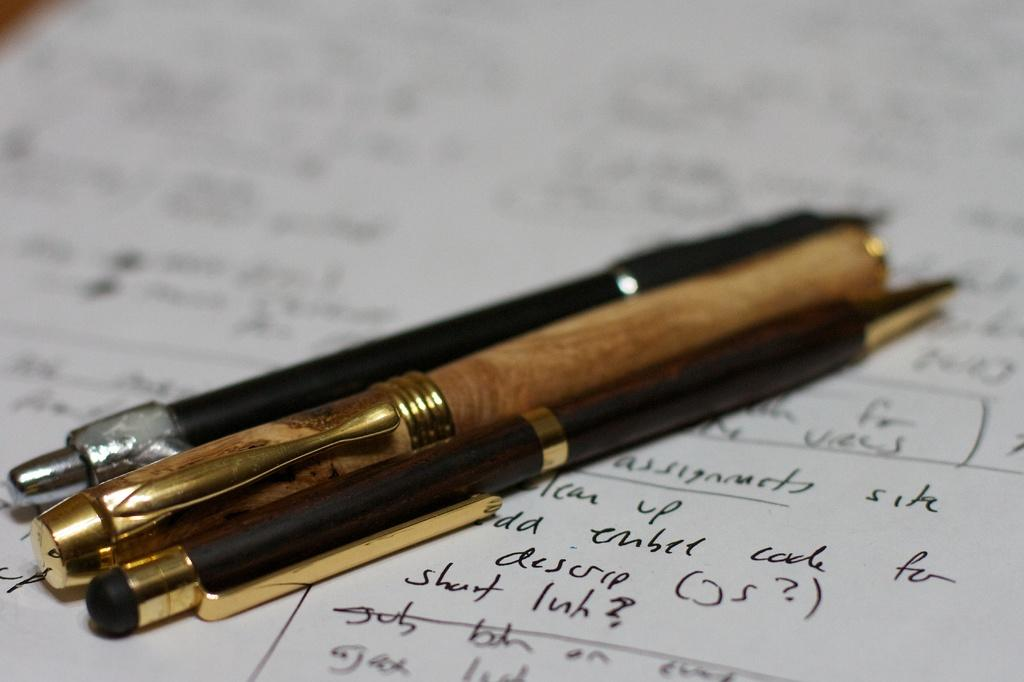<image>
Write a terse but informative summary of the picture. Three pens sitting on top of a paper that has a lot of writing on it that is hard to decipher and part says descrip on it. 